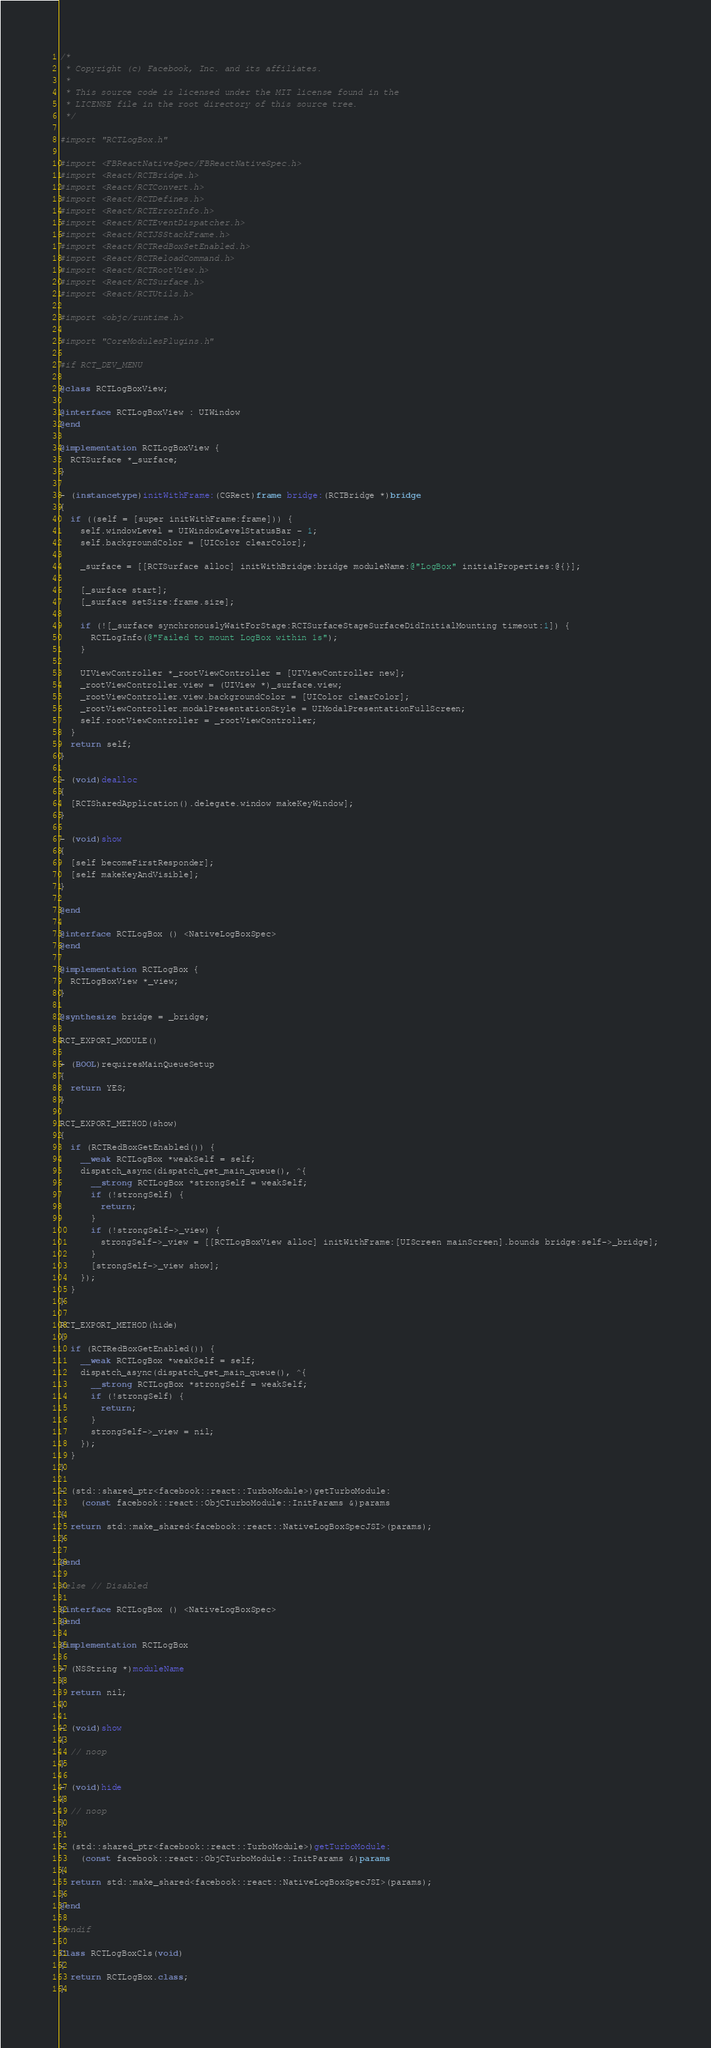<code> <loc_0><loc_0><loc_500><loc_500><_ObjectiveC_>/*
 * Copyright (c) Facebook, Inc. and its affiliates.
 *
 * This source code is licensed under the MIT license found in the
 * LICENSE file in the root directory of this source tree.
 */

#import "RCTLogBox.h"

#import <FBReactNativeSpec/FBReactNativeSpec.h>
#import <React/RCTBridge.h>
#import <React/RCTConvert.h>
#import <React/RCTDefines.h>
#import <React/RCTErrorInfo.h>
#import <React/RCTEventDispatcher.h>
#import <React/RCTJSStackFrame.h>
#import <React/RCTRedBoxSetEnabled.h>
#import <React/RCTReloadCommand.h>
#import <React/RCTRootView.h>
#import <React/RCTSurface.h>
#import <React/RCTUtils.h>

#import <objc/runtime.h>

#import "CoreModulesPlugins.h"

#if RCT_DEV_MENU

@class RCTLogBoxView;

@interface RCTLogBoxView : UIWindow
@end

@implementation RCTLogBoxView {
  RCTSurface *_surface;
}

- (instancetype)initWithFrame:(CGRect)frame bridge:(RCTBridge *)bridge
{
  if ((self = [super initWithFrame:frame])) {
    self.windowLevel = UIWindowLevelStatusBar - 1;
    self.backgroundColor = [UIColor clearColor];

    _surface = [[RCTSurface alloc] initWithBridge:bridge moduleName:@"LogBox" initialProperties:@{}];

    [_surface start];
    [_surface setSize:frame.size];

    if (![_surface synchronouslyWaitForStage:RCTSurfaceStageSurfaceDidInitialMounting timeout:1]) {
      RCTLogInfo(@"Failed to mount LogBox within 1s");
    }

    UIViewController *_rootViewController = [UIViewController new];
    _rootViewController.view = (UIView *)_surface.view;
    _rootViewController.view.backgroundColor = [UIColor clearColor];
    _rootViewController.modalPresentationStyle = UIModalPresentationFullScreen;
    self.rootViewController = _rootViewController;
  }
  return self;
}

- (void)dealloc
{
  [RCTSharedApplication().delegate.window makeKeyWindow];
}

- (void)show
{
  [self becomeFirstResponder];
  [self makeKeyAndVisible];
}

@end

@interface RCTLogBox () <NativeLogBoxSpec>
@end

@implementation RCTLogBox {
  RCTLogBoxView *_view;
}

@synthesize bridge = _bridge;

RCT_EXPORT_MODULE()

+ (BOOL)requiresMainQueueSetup
{
  return YES;
}

RCT_EXPORT_METHOD(show)
{
  if (RCTRedBoxGetEnabled()) {
    __weak RCTLogBox *weakSelf = self;
    dispatch_async(dispatch_get_main_queue(), ^{
      __strong RCTLogBox *strongSelf = weakSelf;
      if (!strongSelf) {
        return;
      }
      if (!strongSelf->_view) {
        strongSelf->_view = [[RCTLogBoxView alloc] initWithFrame:[UIScreen mainScreen].bounds bridge:self->_bridge];
      }
      [strongSelf->_view show];
    });
  }
}

RCT_EXPORT_METHOD(hide)
{
  if (RCTRedBoxGetEnabled()) {
    __weak RCTLogBox *weakSelf = self;
    dispatch_async(dispatch_get_main_queue(), ^{
      __strong RCTLogBox *strongSelf = weakSelf;
      if (!strongSelf) {
        return;
      }
      strongSelf->_view = nil;
    });
  }
}

- (std::shared_ptr<facebook::react::TurboModule>)getTurboModule:
    (const facebook::react::ObjCTurboModule::InitParams &)params
{
  return std::make_shared<facebook::react::NativeLogBoxSpecJSI>(params);
}

@end

#else // Disabled

@interface RCTLogBox () <NativeLogBoxSpec>
@end

@implementation RCTLogBox

+ (NSString *)moduleName
{
  return nil;
}

- (void)show
{
  // noop
}

- (void)hide
{
  // noop
}

- (std::shared_ptr<facebook::react::TurboModule>)getTurboModule:
    (const facebook::react::ObjCTurboModule::InitParams &)params
{
  return std::make_shared<facebook::react::NativeLogBoxSpecJSI>(params);
}
@end

#endif

Class RCTLogBoxCls(void)
{
  return RCTLogBox.class;
}
</code> 